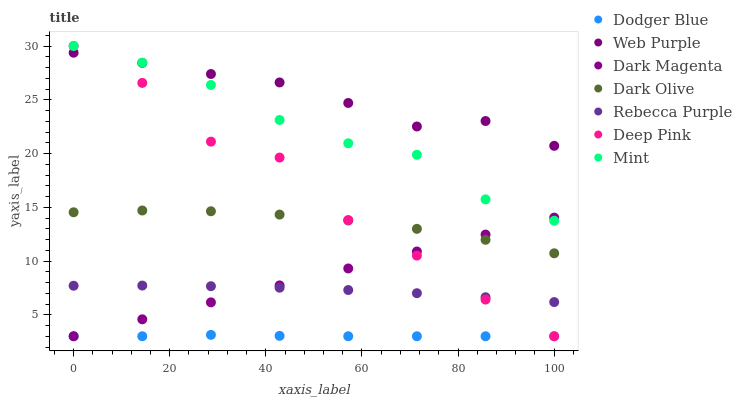Does Dodger Blue have the minimum area under the curve?
Answer yes or no. Yes. Does Web Purple have the maximum area under the curve?
Answer yes or no. Yes. Does Dark Magenta have the minimum area under the curve?
Answer yes or no. No. Does Dark Magenta have the maximum area under the curve?
Answer yes or no. No. Is Dark Magenta the smoothest?
Answer yes or no. Yes. Is Deep Pink the roughest?
Answer yes or no. Yes. Is Dark Olive the smoothest?
Answer yes or no. No. Is Dark Olive the roughest?
Answer yes or no. No. Does Deep Pink have the lowest value?
Answer yes or no. Yes. Does Dark Olive have the lowest value?
Answer yes or no. No. Does Mint have the highest value?
Answer yes or no. Yes. Does Dark Magenta have the highest value?
Answer yes or no. No. Is Dodger Blue less than Dark Olive?
Answer yes or no. Yes. Is Dark Olive greater than Rebecca Purple?
Answer yes or no. Yes. Does Deep Pink intersect Mint?
Answer yes or no. Yes. Is Deep Pink less than Mint?
Answer yes or no. No. Is Deep Pink greater than Mint?
Answer yes or no. No. Does Dodger Blue intersect Dark Olive?
Answer yes or no. No. 